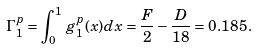Convert formula to latex. <formula><loc_0><loc_0><loc_500><loc_500>\Gamma _ { 1 } ^ { p } = \int _ { 0 } ^ { 1 } \, g _ { 1 } ^ { p } ( x ) d x = \frac { F } { 2 } - \frac { D } { 1 8 } = 0 . 1 8 5 \, .</formula> 